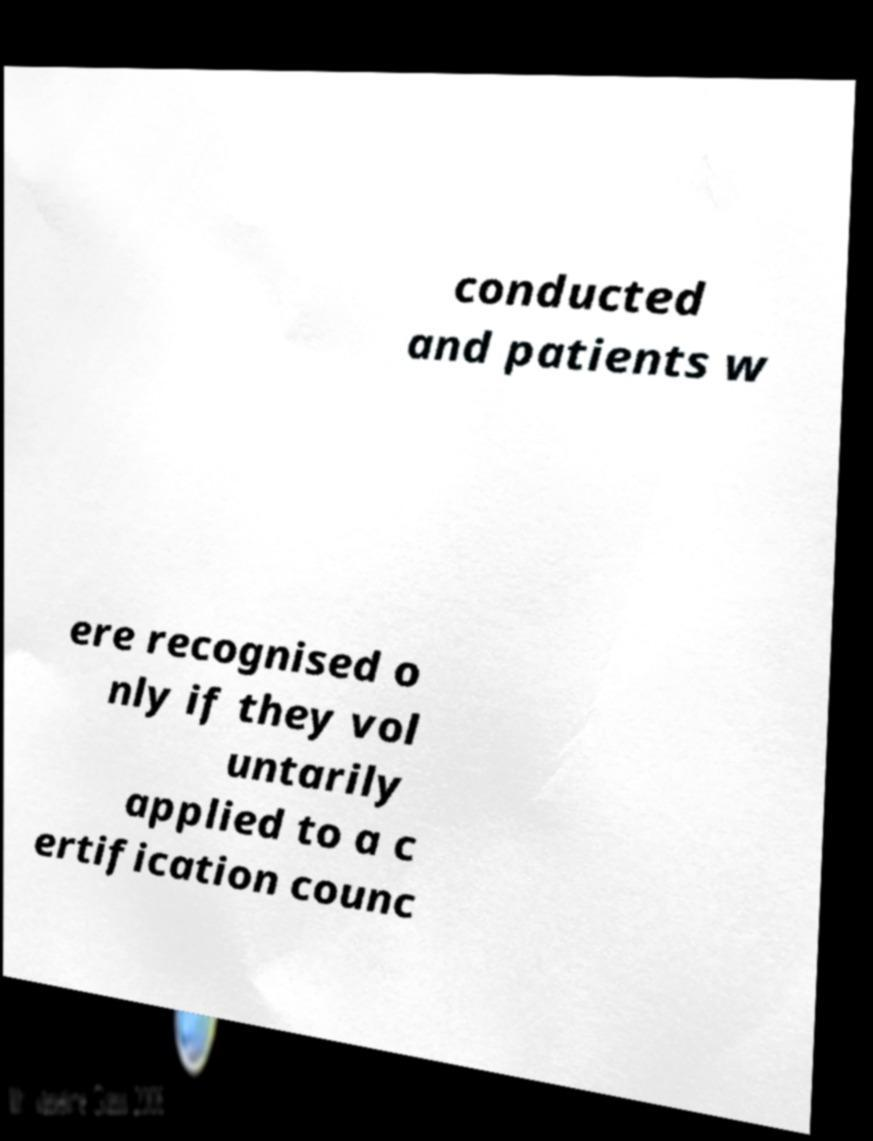Please read and relay the text visible in this image. What does it say? conducted and patients w ere recognised o nly if they vol untarily applied to a c ertification counc 